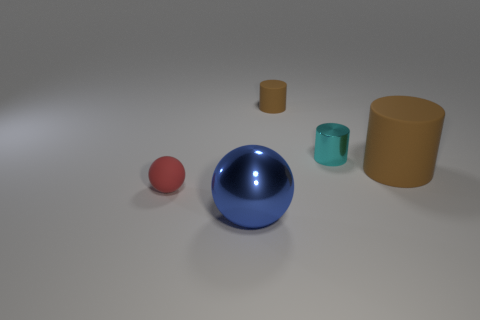Are there any large blue things that have the same material as the blue sphere?
Provide a succinct answer. No. The matte object that is the same color as the large cylinder is what size?
Offer a very short reply. Small. There is a metal object that is behind the red rubber object; is its size the same as the thing that is on the left side of the blue object?
Ensure brevity in your answer.  Yes. There is a rubber thing to the left of the blue ball; how big is it?
Keep it short and to the point. Small. Are there any metallic things of the same color as the matte sphere?
Your answer should be compact. No. There is a shiny thing that is in front of the tiny sphere; is there a large metallic ball to the left of it?
Make the answer very short. No. There is a blue metallic object; does it have the same size as the metal object that is behind the red rubber sphere?
Give a very brief answer. No. There is a shiny thing in front of the tiny object that is left of the big blue metal ball; is there a tiny ball on the right side of it?
Provide a short and direct response. No. There is a sphere that is in front of the tiny red rubber thing; what material is it?
Give a very brief answer. Metal. Does the cyan shiny object have the same size as the blue metal object?
Give a very brief answer. No. 